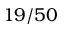Convert formula to latex. <formula><loc_0><loc_0><loc_500><loc_500>1 9 / 5 0</formula> 